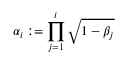<formula> <loc_0><loc_0><loc_500><loc_500>\alpha _ { i } \colon = \prod _ { j = 1 } ^ { i } \sqrt { 1 - \beta _ { j } }</formula> 